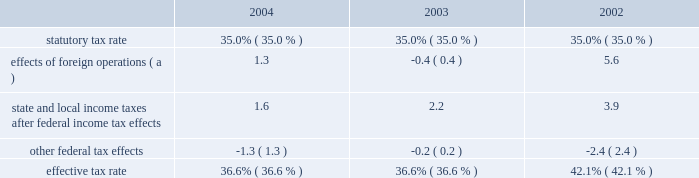Gain or loss on ownership change in map results from contributions to map of certain environmental capital expenditures and leased property acquisitions funded by marathon and ashland .
In accordance with map 2019s limited liability company agreement , in certain instances , environmental capital expenditures and acquisitions of leased properties are funded by the original contributor of the assets , but no change in ownership interest may result from these contributions .
An excess of ashland funded improvements over marathon funded improvements results in a net gain and an excess of marathon funded improvements over ashland funded improvements results in a net loss .
Cost of revenues increased by $ 5.822 billion in 2004 from 2003 and by $ 6.040 billion in 2003 from 2002 .
The increases are primarily in the rm&t segment and result from higher acquisition costs for crude oil , refined products , refinery charge and blend feedstocks and increased manufacturing expenses .
Selling , general and administrative expenses increased by $ 105 million in 2004 from 2003 and by $ 97 million in 2003 from 2002 .
The increase in 2004 was primarily due to increased stock-based compensation and higher costs associated with business transformation and outsourcing .
Our 2004 results were also impacted by start-up costs associated with the lng project in equatorial guinea and the increased cost of complying with governmental regulations .
The increase in 2003 was primarily due to increased employee benefit expenses ( caused by increased pension expense resulting from changes in actuarial assumptions and a decrease in realized returns on plan assets ) and other employee related costs .
Additionally , during 2003 , we recorded a charge of $ 24 million related to organizational and business process changes .
Inventory market valuation reserve ( 2018 2018imv 2019 2019 ) is established to reduce the cost basis of inventories to current market value .
Generally , we will establish an imv reserve when crude oil prices fall below $ 22 per barrel .
The 2002 results of operations include credits to income from operations of $ 71 million , reversing the imv reserve at december 31 , 2001 .
Net interest and other financial costs decreased by $ 25 million in 2004 from 2003 and by $ 82 million in 2003 from 2002 .
The decrease in 2004 is primarily due to an increase in interest income .
The decrease in 2003 is primarily due to an increase in capitalized interest related to increased long-term construction projects , the favorable effect of interest rate swaps , the favorable effect of a reduction in interest on tax deficiencies and increased interest income on investments .
Additionally , included in net interest and other financing costs are foreign currency gains of $ 9 million , $ 13 million and $ 8 million for 2004 , 2003 and 2002 .
Loss from early extinguishment of debt in 2002 was attributable to the retirement of $ 337 million aggregate principal amount of debt , resulting in a loss of $ 53 million .
Minority interest in income of map , which represents ashland 2019s 38 percent ownership interest , increased by $ 230 million in 2004 from 2003 and by $ 129 million in 2003 from 2002 .
Map income was higher in 2004 compared to 2003 and in 2003 compared to 2002 as discussed below in the rm&t segment .
Minority interest in loss of equatorial guinea lng holdings limited , which represents gepetrol 2019s 25 percent ownership interest , was $ 7 million in 2004 , primarily resulting from gepetrol 2019s share of start-up costs associated with the lng project in equatorial guinea .
Provision for income taxes increased by $ 143 million in 2004 from 2003 and by $ 215 million in 2003 from 2002 , primarily due to $ 388 million and $ 720 million increases in income before income taxes .
The effective tax rate for 2004 was 36.6 percent compared to 36.6 percent and 42.1 percent for 2003 and 2002 .
The higher rate in 2002 was due to the united kingdom enactment of a supplementary 10 percent tax on profits from the north sea oil and gas production , retroactively effective to april 17 , 2002 .
In 2002 , we recognized a one-time noncash deferred tax adjustment of $ 61 million as a result of the rate increase .
The following is an analysis of the effective tax rate for the periods presented: .
( a ) the deferred tax effect related to the enactment of a supplemental tax in the u.k .
Increased the effective tax rate 7.0 percent in .
What was the total included in net interest and other financing costs are foreign currency gains for 2004 , 2003 and 2002 in millions? 
Computations: ((9 + 13) + 8)
Answer: 30.0. Gain or loss on ownership change in map results from contributions to map of certain environmental capital expenditures and leased property acquisitions funded by marathon and ashland .
In accordance with map 2019s limited liability company agreement , in certain instances , environmental capital expenditures and acquisitions of leased properties are funded by the original contributor of the assets , but no change in ownership interest may result from these contributions .
An excess of ashland funded improvements over marathon funded improvements results in a net gain and an excess of marathon funded improvements over ashland funded improvements results in a net loss .
Cost of revenues increased by $ 5.822 billion in 2004 from 2003 and by $ 6.040 billion in 2003 from 2002 .
The increases are primarily in the rm&t segment and result from higher acquisition costs for crude oil , refined products , refinery charge and blend feedstocks and increased manufacturing expenses .
Selling , general and administrative expenses increased by $ 105 million in 2004 from 2003 and by $ 97 million in 2003 from 2002 .
The increase in 2004 was primarily due to increased stock-based compensation and higher costs associated with business transformation and outsourcing .
Our 2004 results were also impacted by start-up costs associated with the lng project in equatorial guinea and the increased cost of complying with governmental regulations .
The increase in 2003 was primarily due to increased employee benefit expenses ( caused by increased pension expense resulting from changes in actuarial assumptions and a decrease in realized returns on plan assets ) and other employee related costs .
Additionally , during 2003 , we recorded a charge of $ 24 million related to organizational and business process changes .
Inventory market valuation reserve ( 2018 2018imv 2019 2019 ) is established to reduce the cost basis of inventories to current market value .
Generally , we will establish an imv reserve when crude oil prices fall below $ 22 per barrel .
The 2002 results of operations include credits to income from operations of $ 71 million , reversing the imv reserve at december 31 , 2001 .
Net interest and other financial costs decreased by $ 25 million in 2004 from 2003 and by $ 82 million in 2003 from 2002 .
The decrease in 2004 is primarily due to an increase in interest income .
The decrease in 2003 is primarily due to an increase in capitalized interest related to increased long-term construction projects , the favorable effect of interest rate swaps , the favorable effect of a reduction in interest on tax deficiencies and increased interest income on investments .
Additionally , included in net interest and other financing costs are foreign currency gains of $ 9 million , $ 13 million and $ 8 million for 2004 , 2003 and 2002 .
Loss from early extinguishment of debt in 2002 was attributable to the retirement of $ 337 million aggregate principal amount of debt , resulting in a loss of $ 53 million .
Minority interest in income of map , which represents ashland 2019s 38 percent ownership interest , increased by $ 230 million in 2004 from 2003 and by $ 129 million in 2003 from 2002 .
Map income was higher in 2004 compared to 2003 and in 2003 compared to 2002 as discussed below in the rm&t segment .
Minority interest in loss of equatorial guinea lng holdings limited , which represents gepetrol 2019s 25 percent ownership interest , was $ 7 million in 2004 , primarily resulting from gepetrol 2019s share of start-up costs associated with the lng project in equatorial guinea .
Provision for income taxes increased by $ 143 million in 2004 from 2003 and by $ 215 million in 2003 from 2002 , primarily due to $ 388 million and $ 720 million increases in income before income taxes .
The effective tax rate for 2004 was 36.6 percent compared to 36.6 percent and 42.1 percent for 2003 and 2002 .
The higher rate in 2002 was due to the united kingdom enactment of a supplementary 10 percent tax on profits from the north sea oil and gas production , retroactively effective to april 17 , 2002 .
In 2002 , we recognized a one-time noncash deferred tax adjustment of $ 61 million as a result of the rate increase .
The following is an analysis of the effective tax rate for the periods presented: .
( a ) the deferred tax effect related to the enactment of a supplemental tax in the u.k .
Increased the effective tax rate 7.0 percent in .
For the three year period , what were average state and local income taxes after federal income tax effects , in millions? 
Computations: table_average(state and local income taxes after federal income tax effects, none)
Answer: 2.56667. Gain or loss on ownership change in map results from contributions to map of certain environmental capital expenditures and leased property acquisitions funded by marathon and ashland .
In accordance with map 2019s limited liability company agreement , in certain instances , environmental capital expenditures and acquisitions of leased properties are funded by the original contributor of the assets , but no change in ownership interest may result from these contributions .
An excess of ashland funded improvements over marathon funded improvements results in a net gain and an excess of marathon funded improvements over ashland funded improvements results in a net loss .
Cost of revenues increased by $ 5.822 billion in 2004 from 2003 and by $ 6.040 billion in 2003 from 2002 .
The increases are primarily in the rm&t segment and result from higher acquisition costs for crude oil , refined products , refinery charge and blend feedstocks and increased manufacturing expenses .
Selling , general and administrative expenses increased by $ 105 million in 2004 from 2003 and by $ 97 million in 2003 from 2002 .
The increase in 2004 was primarily due to increased stock-based compensation and higher costs associated with business transformation and outsourcing .
Our 2004 results were also impacted by start-up costs associated with the lng project in equatorial guinea and the increased cost of complying with governmental regulations .
The increase in 2003 was primarily due to increased employee benefit expenses ( caused by increased pension expense resulting from changes in actuarial assumptions and a decrease in realized returns on plan assets ) and other employee related costs .
Additionally , during 2003 , we recorded a charge of $ 24 million related to organizational and business process changes .
Inventory market valuation reserve ( 2018 2018imv 2019 2019 ) is established to reduce the cost basis of inventories to current market value .
Generally , we will establish an imv reserve when crude oil prices fall below $ 22 per barrel .
The 2002 results of operations include credits to income from operations of $ 71 million , reversing the imv reserve at december 31 , 2001 .
Net interest and other financial costs decreased by $ 25 million in 2004 from 2003 and by $ 82 million in 2003 from 2002 .
The decrease in 2004 is primarily due to an increase in interest income .
The decrease in 2003 is primarily due to an increase in capitalized interest related to increased long-term construction projects , the favorable effect of interest rate swaps , the favorable effect of a reduction in interest on tax deficiencies and increased interest income on investments .
Additionally , included in net interest and other financing costs are foreign currency gains of $ 9 million , $ 13 million and $ 8 million for 2004 , 2003 and 2002 .
Loss from early extinguishment of debt in 2002 was attributable to the retirement of $ 337 million aggregate principal amount of debt , resulting in a loss of $ 53 million .
Minority interest in income of map , which represents ashland 2019s 38 percent ownership interest , increased by $ 230 million in 2004 from 2003 and by $ 129 million in 2003 from 2002 .
Map income was higher in 2004 compared to 2003 and in 2003 compared to 2002 as discussed below in the rm&t segment .
Minority interest in loss of equatorial guinea lng holdings limited , which represents gepetrol 2019s 25 percent ownership interest , was $ 7 million in 2004 , primarily resulting from gepetrol 2019s share of start-up costs associated with the lng project in equatorial guinea .
Provision for income taxes increased by $ 143 million in 2004 from 2003 and by $ 215 million in 2003 from 2002 , primarily due to $ 388 million and $ 720 million increases in income before income taxes .
The effective tax rate for 2004 was 36.6 percent compared to 36.6 percent and 42.1 percent for 2003 and 2002 .
The higher rate in 2002 was due to the united kingdom enactment of a supplementary 10 percent tax on profits from the north sea oil and gas production , retroactively effective to april 17 , 2002 .
In 2002 , we recognized a one-time noncash deferred tax adjustment of $ 61 million as a result of the rate increase .
The following is an analysis of the effective tax rate for the periods presented: .
( a ) the deferred tax effect related to the enactment of a supplemental tax in the u.k .
Increased the effective tax rate 7.0 percent in .
By what percent did effects of foreign operations decrease from 2002 to 2004? 
Computations: ((1.3 - 5.6) / 5.6)
Answer: -0.76786. 